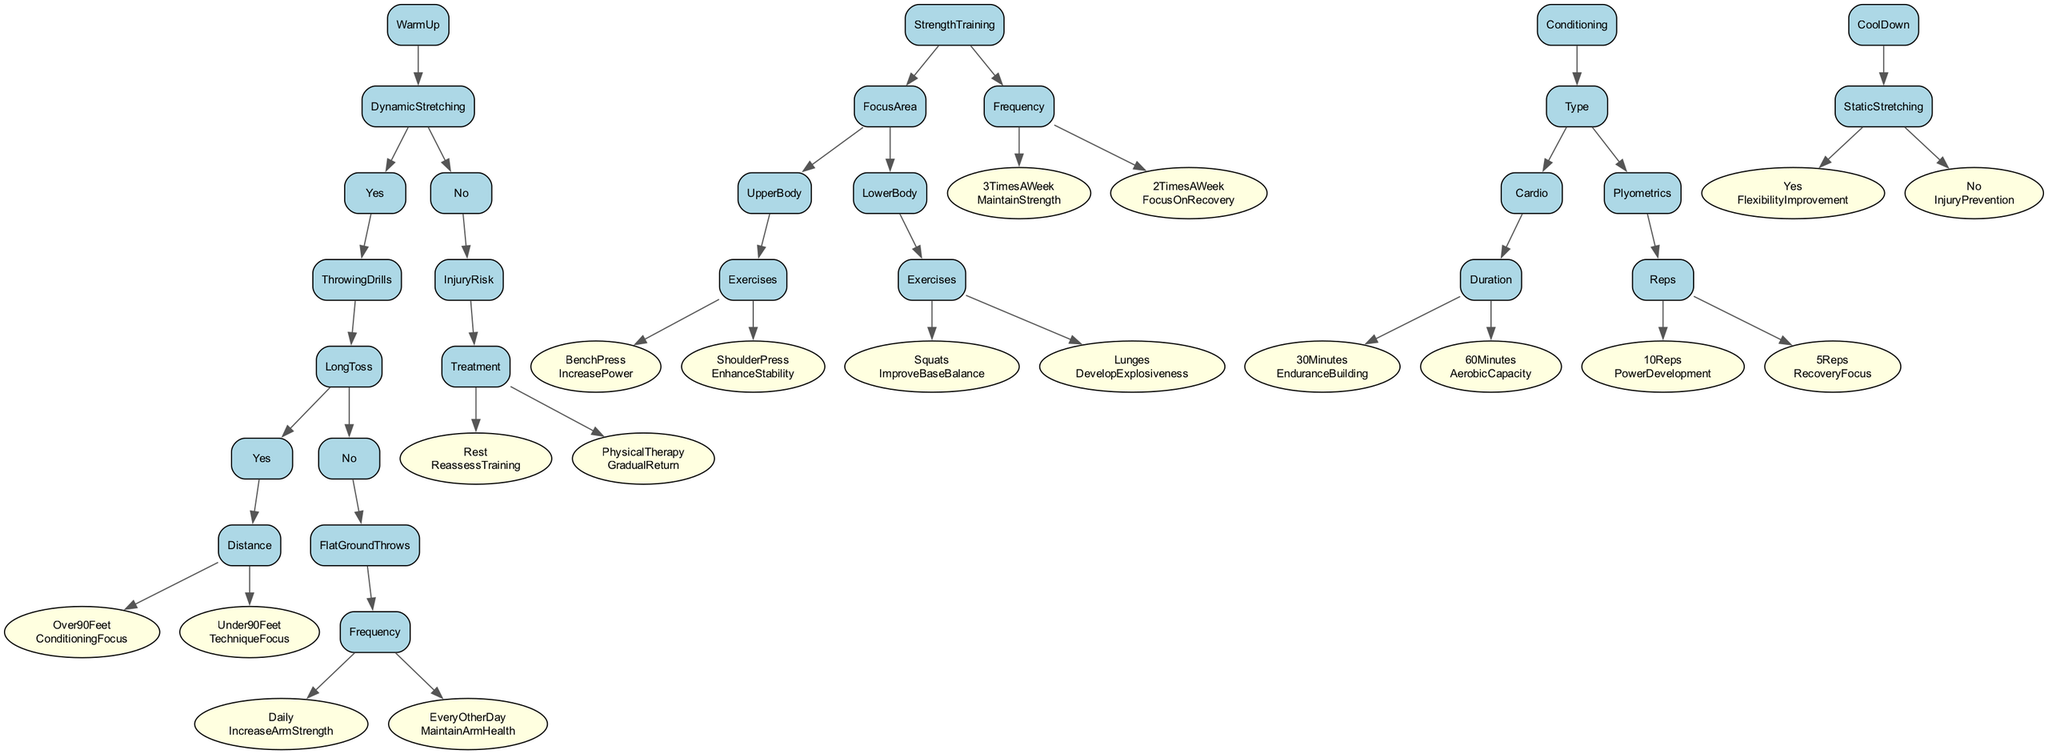What is the first step in the training regimen? The first step in the training regimen involves a warm-up, which may include dynamic stretching or not.
Answer: WarmUp If the dynamic stretching is "No," what is the next node? If dynamic stretching is "No," the next node is "InjuryRisk." This node focuses on assessing the risk of injury.
Answer: InjuryRisk How many different strength training frequencies are mentioned? The diagram specifies two frequencies for strength training: "3 Times A Week" and "2 Times A Week."
Answer: 2 What is the outcome if the "Frequency" for FlatGroundThrows is "Daily"? If FlatGroundThrows is done "Daily," the outcome is "IncreaseArmStrength," indicating a focus on enhancing the arm's power and strength.
Answer: IncreaseArmStrength What is the focus area if the strength training is for upper body? If the focus area is upper body, it includes exercises like "BenchPress" and "ShoulderPress," which aim to increase power and enhance stability, respectively.
Answer: UpperBody If a pitcher does "30 Minutes" of cardio, what is the training focus? Doing "30 Minutes" of cardio focuses on "EnduranceBuilding," which is essential for maintaining energy and performance during games.
Answer: EnduranceBuilding What happens if the distance in LongToss is "Under90Feet"? If the distance in LongToss is "Under90Feet," the focus will be on "TechniqueFocus," which emphasizes improving the throwing mechanics of the pitcher.
Answer: TechniqueFocus Which type of exercise is associated with improving base balance? The type of exercise associated with improving base balance is "Squats," which enhance stability during pitching and other movements.
Answer: Squats What is the recommended action if injury risk is assessed? If injury risk is assessed, the recommendations could include either "Rest," which prompts reassessment of training, or "PhysicalTherapy," indicating a gradual return to training.
Answer: Rest or PhysicalTherapy 